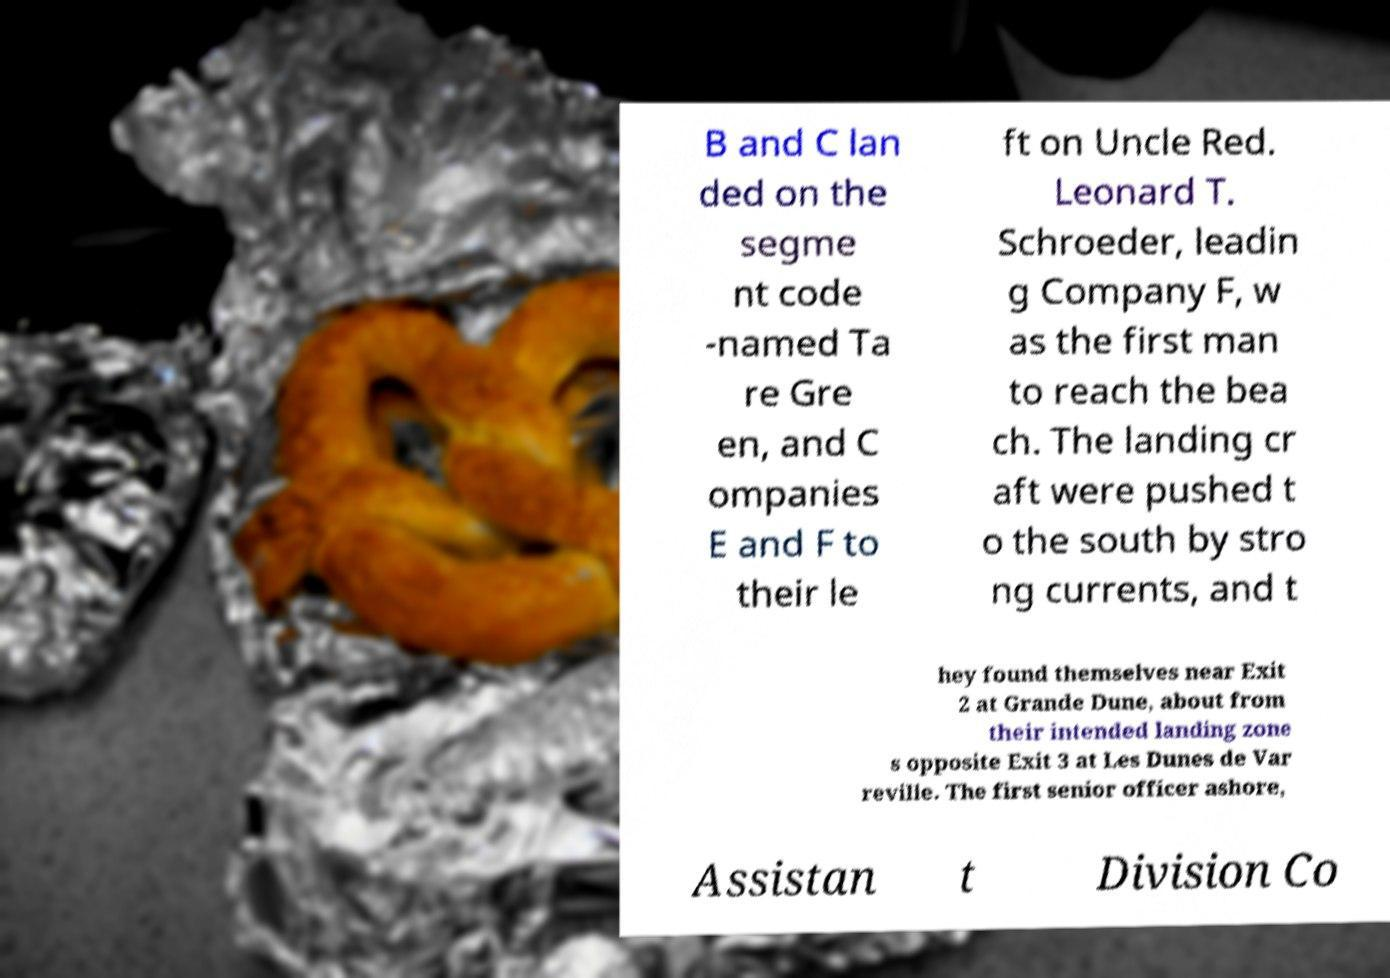Could you extract and type out the text from this image? B and C lan ded on the segme nt code -named Ta re Gre en, and C ompanies E and F to their le ft on Uncle Red. Leonard T. Schroeder, leadin g Company F, w as the first man to reach the bea ch. The landing cr aft were pushed t o the south by stro ng currents, and t hey found themselves near Exit 2 at Grande Dune, about from their intended landing zone s opposite Exit 3 at Les Dunes de Var reville. The first senior officer ashore, Assistan t Division Co 